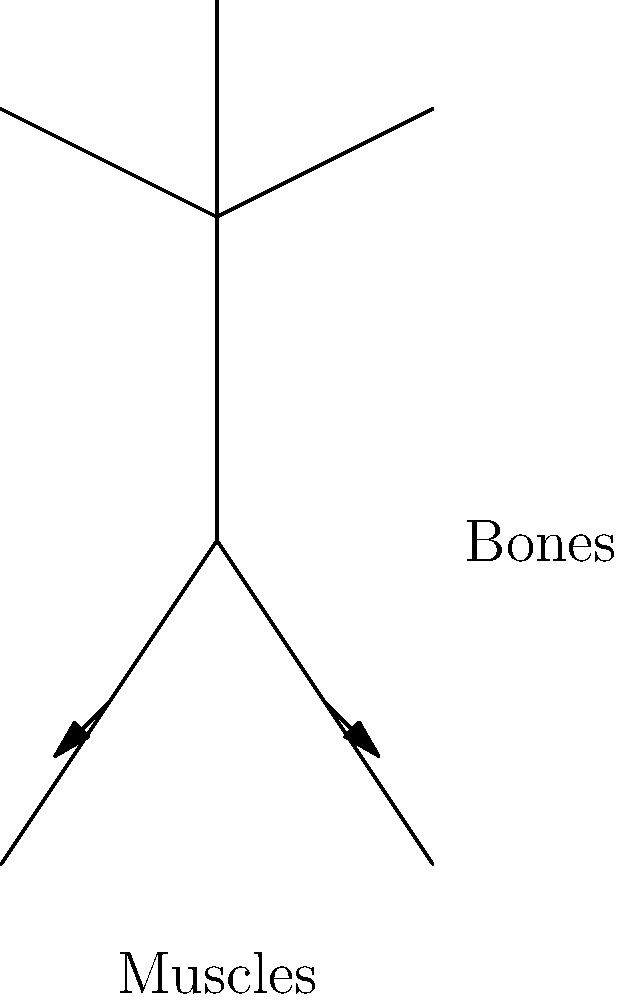Look at the stick figure. How do the muscles and bones work together to make the figure walk? Let's break down how muscles and bones work together to make the stick figure walk:

1. Bones: The stick figure's legs are made of bones. These bones act like a frame that gives the body shape and support.

2. Muscles: The arrows in the picture show where the muscles are. Muscles are like stretchy bands attached to the bones.

3. Muscle contraction: When a muscle gets shorter (contracts), it pulls on the bone it's attached to.

4. Alternating leg movements:
   - To take a step, the muscles in one leg contract, pulling that leg forward.
   - At the same time, the muscles in the other leg relax, allowing it to stay back.

5. Repeated action: This process of muscle contraction and relaxation happens over and over, alternating between the legs.

6. Result: As the muscles keep pulling the bones forward one at a time, it makes the stick figure walk!

This teamwork between muscles and bones is what allows us to move and walk.
Answer: Muscles contract to pull bones, moving legs alternately for walking. 